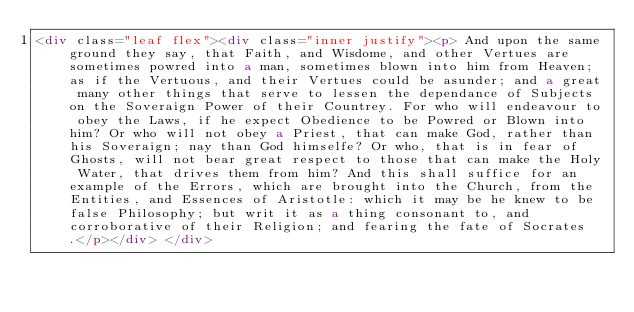<code> <loc_0><loc_0><loc_500><loc_500><_HTML_><div class="leaf flex"><div class="inner justify"><p> And upon the same ground they say, that Faith, and Wisdome, and other Vertues are sometimes powred into a man, sometimes blown into him from Heaven; as if the Vertuous, and their Vertues could be asunder; and a great many other things that serve to lessen the dependance of Subjects on the Soveraign Power of their Countrey. For who will endeavour to obey the Laws, if he expect Obedience to be Powred or Blown into him? Or who will not obey a Priest, that can make God, rather than his Soveraign; nay than God himselfe? Or who, that is in fear of Ghosts, will not bear great respect to those that can make the Holy Water, that drives them from him? And this shall suffice for an example of the Errors, which are brought into the Church, from the Entities, and Essences of Aristotle: which it may be he knew to be false Philosophy; but writ it as a thing consonant to, and corroborative of their Religion; and fearing the fate of Socrates.</p></div> </div></code> 